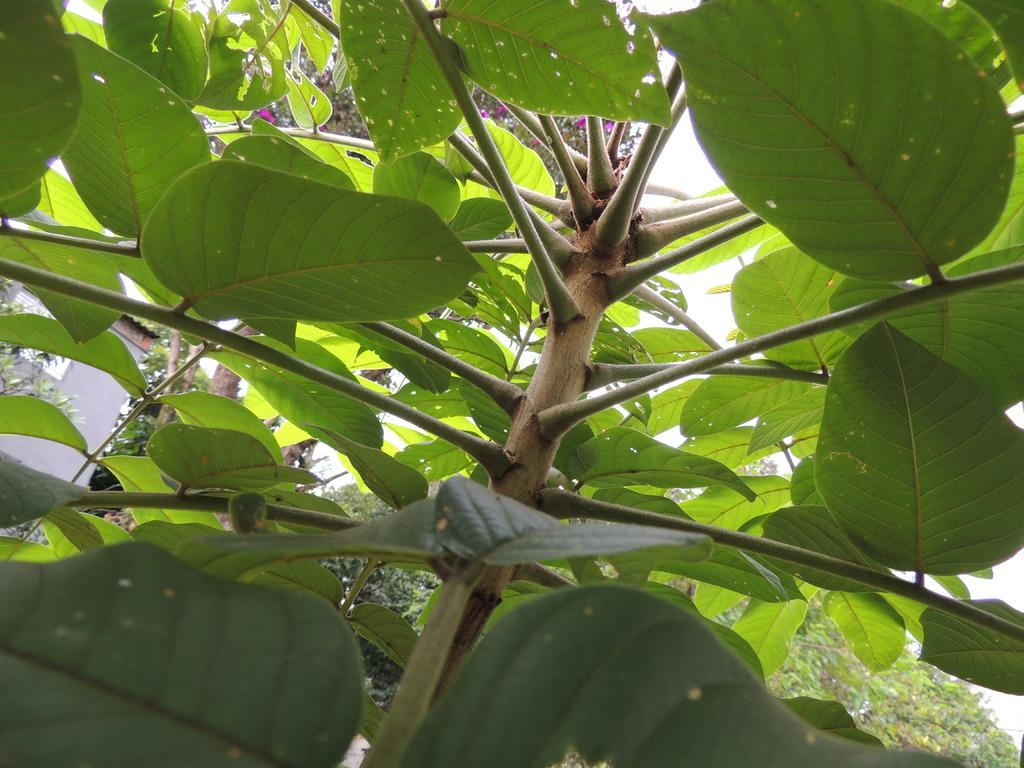What type of living organism can be seen in the image? There is a plant in the image. What specific part of the plant is visible? The plant has leaves. What can be seen through the gaps in the leaves? Trees and a house are visible through the gaps in the leaves. How many passengers are on the plant in the image? There are no passengers on the plant, as it is a living organism and not a mode of transportation. 